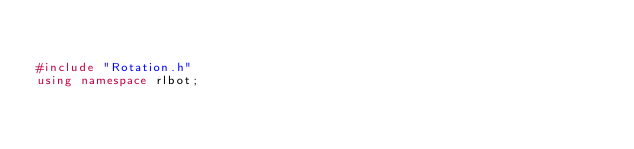Convert code to text. <code><loc_0><loc_0><loc_500><loc_500><_C++_>

#include "Rotation.h"
using namespace rlbot;

</code> 